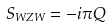Convert formula to latex. <formula><loc_0><loc_0><loc_500><loc_500>S _ { W Z W } = - i \pi Q</formula> 